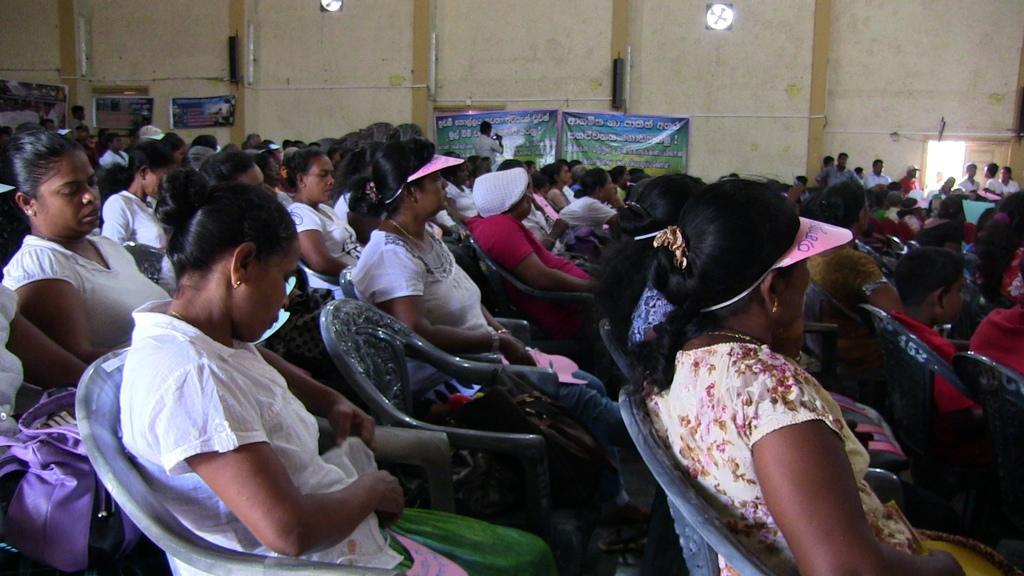Please provide a concise description of this image. This picture shows few people seated on the chairs in an open hall and we see few people standing at the entrance and we see posters on the wall and few of them were semi caps. 